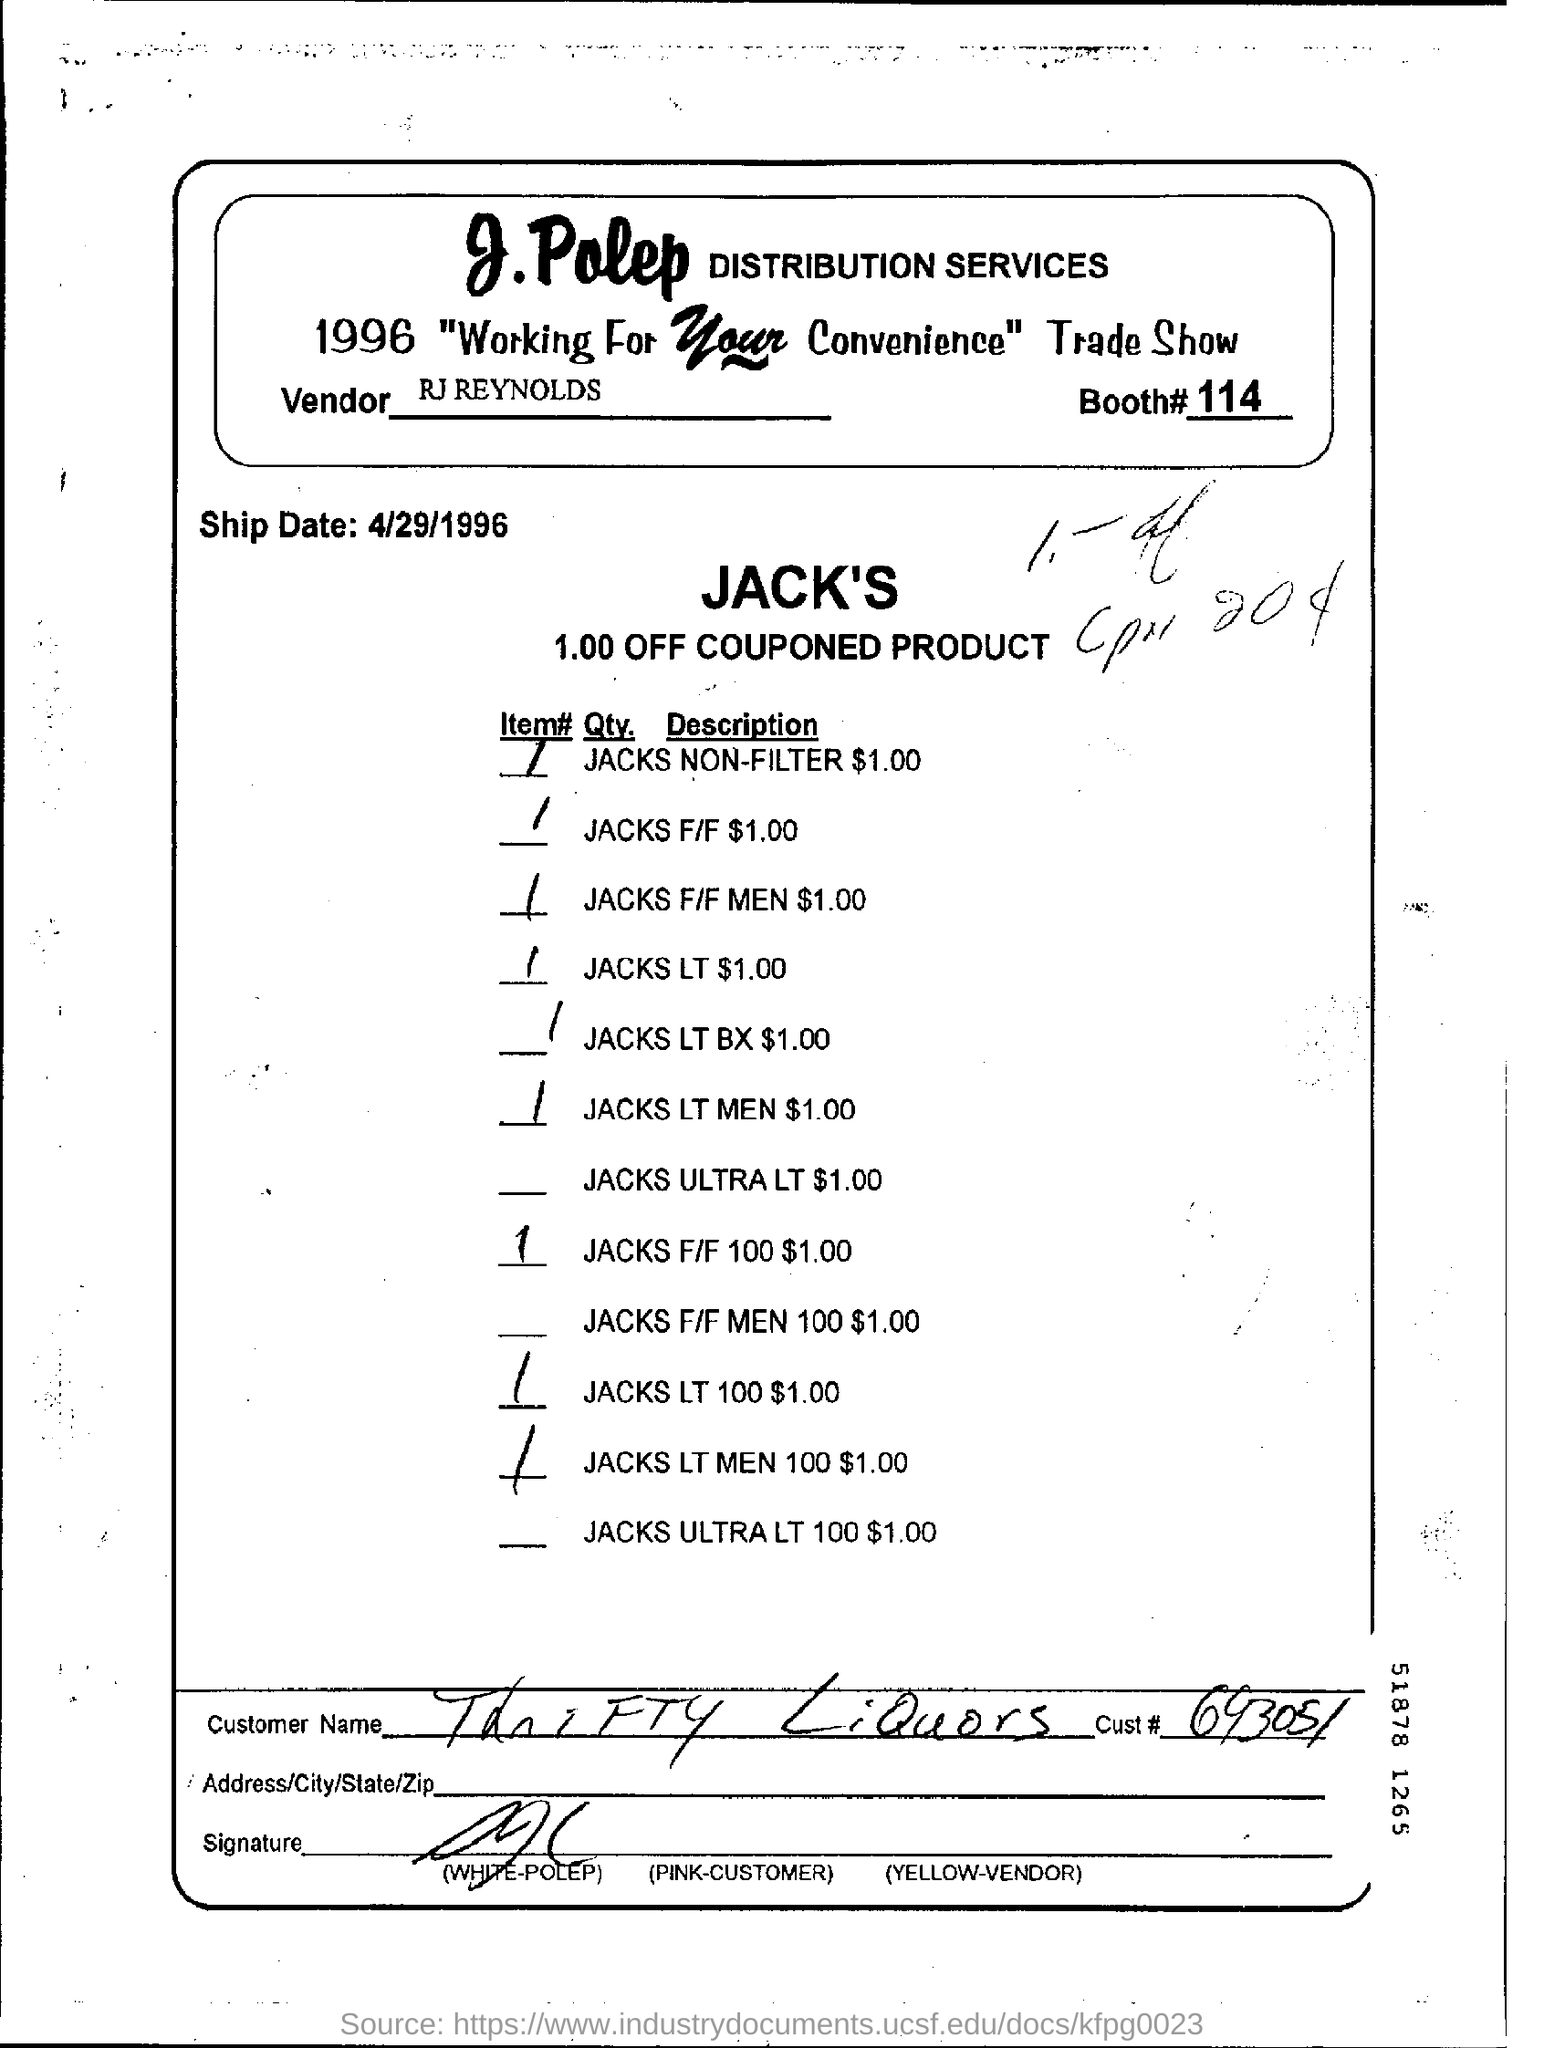Who is the vendor ?
Offer a terse response. RJ Reynolds. What is the booth #?
Your answer should be compact. 114. Mention the ship date ?
Your answer should be very brief. 4/29/1996. How much is off couponed product ?
Your answer should be very brief. 1.00. 